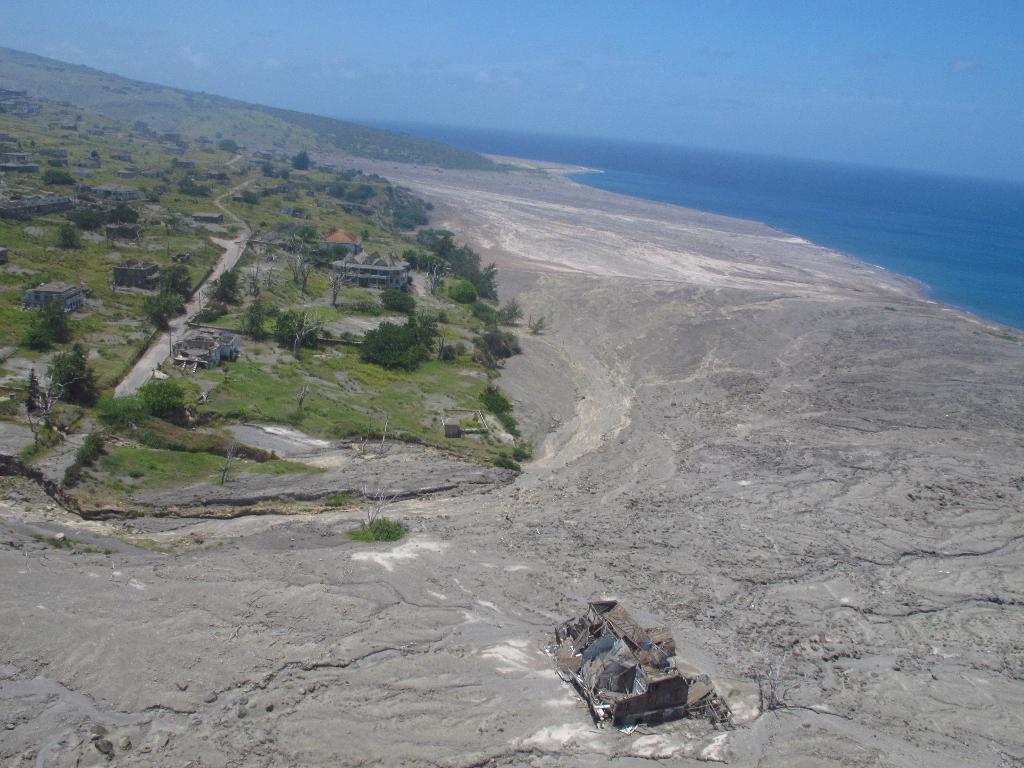Please provide a concise description of this image. In this image we can see the houses, trees, grass and ground. And we can see the water. At the top we can see the sky. 